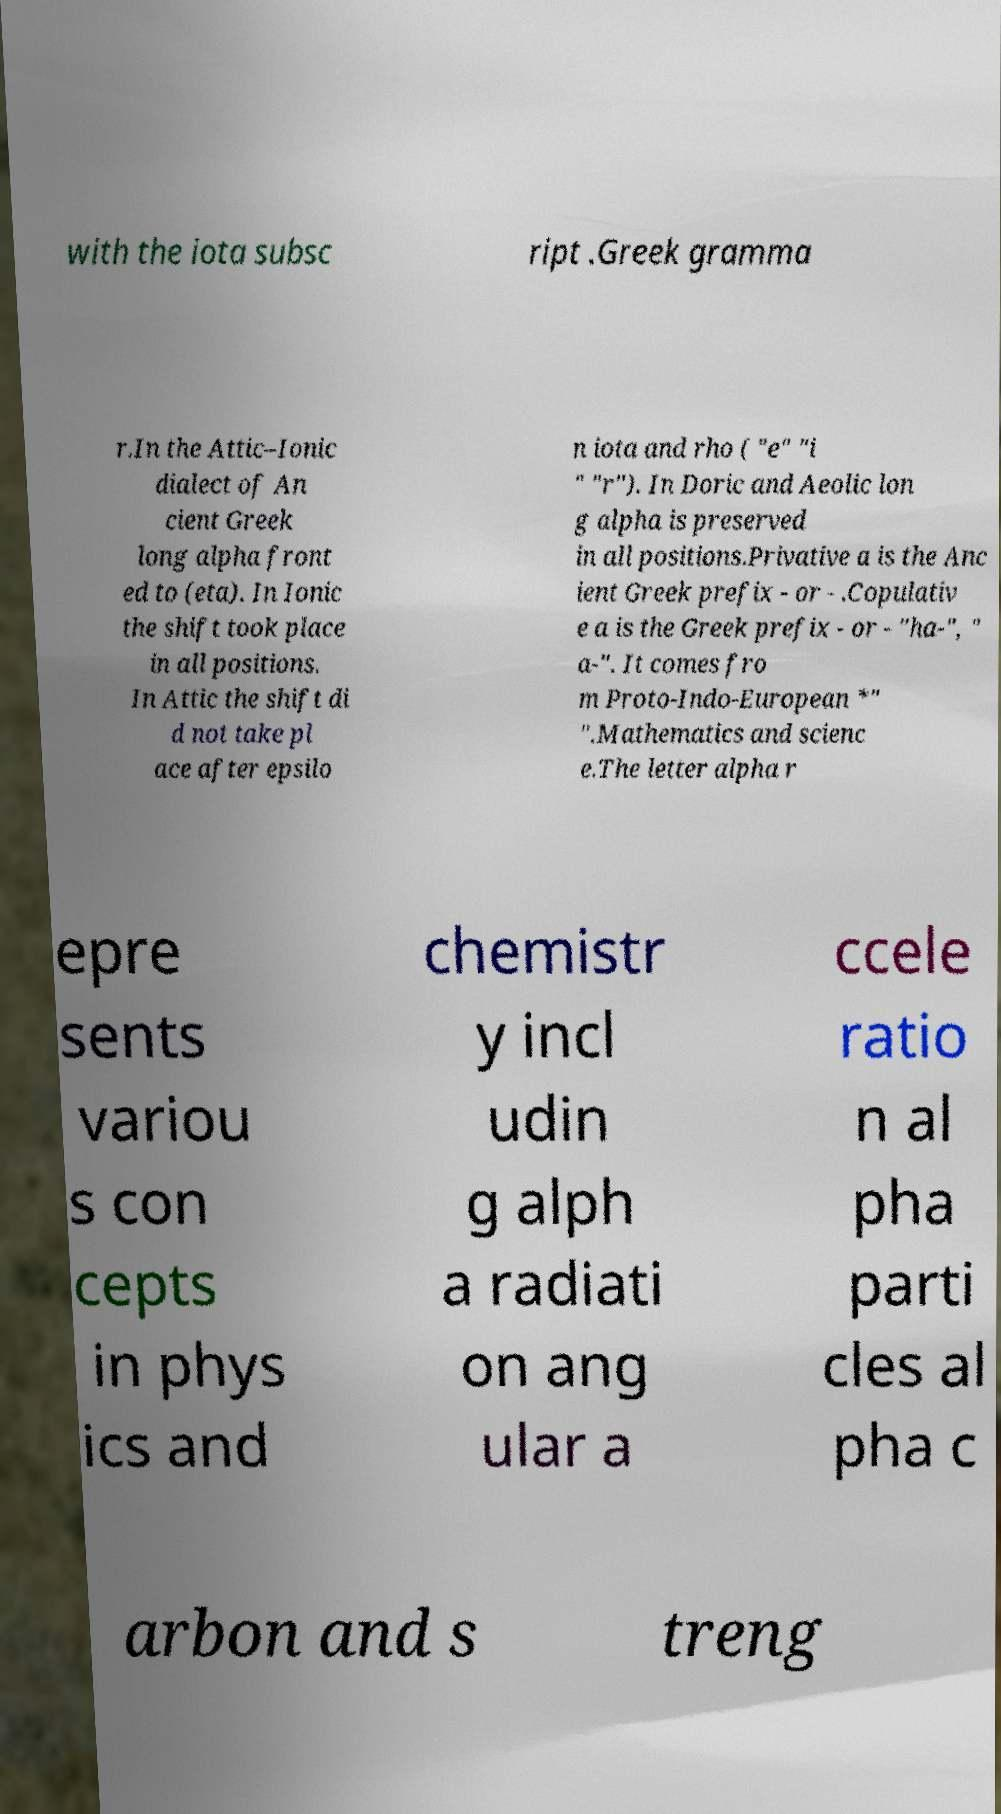Could you extract and type out the text from this image? with the iota subsc ript .Greek gramma r.In the Attic–Ionic dialect of An cient Greek long alpha front ed to (eta). In Ionic the shift took place in all positions. In Attic the shift di d not take pl ace after epsilo n iota and rho ( "e" "i " "r"). In Doric and Aeolic lon g alpha is preserved in all positions.Privative a is the Anc ient Greek prefix - or - .Copulativ e a is the Greek prefix - or - "ha-", " a-". It comes fro m Proto-Indo-European *" ".Mathematics and scienc e.The letter alpha r epre sents variou s con cepts in phys ics and chemistr y incl udin g alph a radiati on ang ular a ccele ratio n al pha parti cles al pha c arbon and s treng 